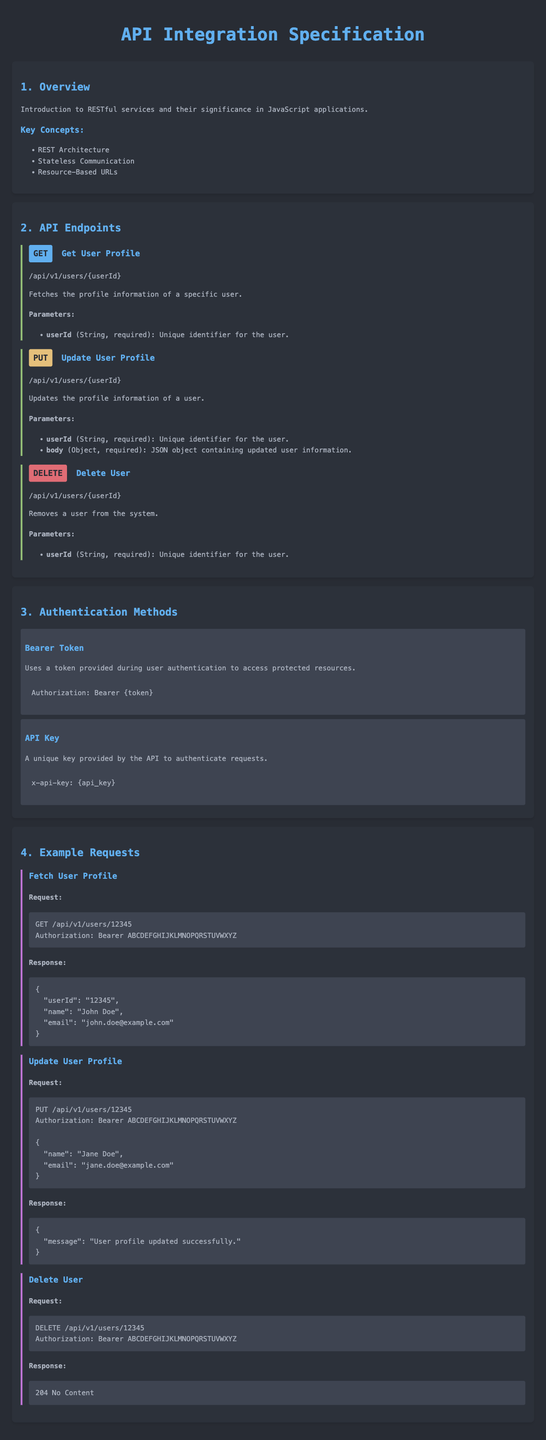What is the title of the document? The title of the document is specified in the head section as "API Integration Specification".
Answer: API Integration Specification How many API endpoints are listed in the document? The document contains three API endpoints under the "API Endpoints" section.
Answer: 3 What is the HTTP method used to delete a user? The method to delete a user is indicated as "DELETE" in the corresponding endpoint section.
Answer: DELETE What type of authentication method uses a token? The authentication method that uses a token is described as "Bearer Token".
Answer: Bearer Token What is one required parameter for the "Get User Profile" endpoint? The endpoint specifies "userId" as a required parameter for fetching a user profile.
Answer: userId What is the expected response status code when a user is deleted? The response status code for a successful delete operation is specified as "204 No Content".
Answer: 204 No Content Which example request updates a user’s email? The example request that updates a user’s email is the "Update User Profile" request shown in the examples section.
Answer: Update User Profile What content type is the body expected to be for the "Update User Profile" endpoint? The body for the "Update User Profile" endpoint is expected to be a JSON object.
Answer: JSON object What HTTP method is used for fetching the user profile? The method used for fetching the user profile is indicated as "GET".
Answer: GET 